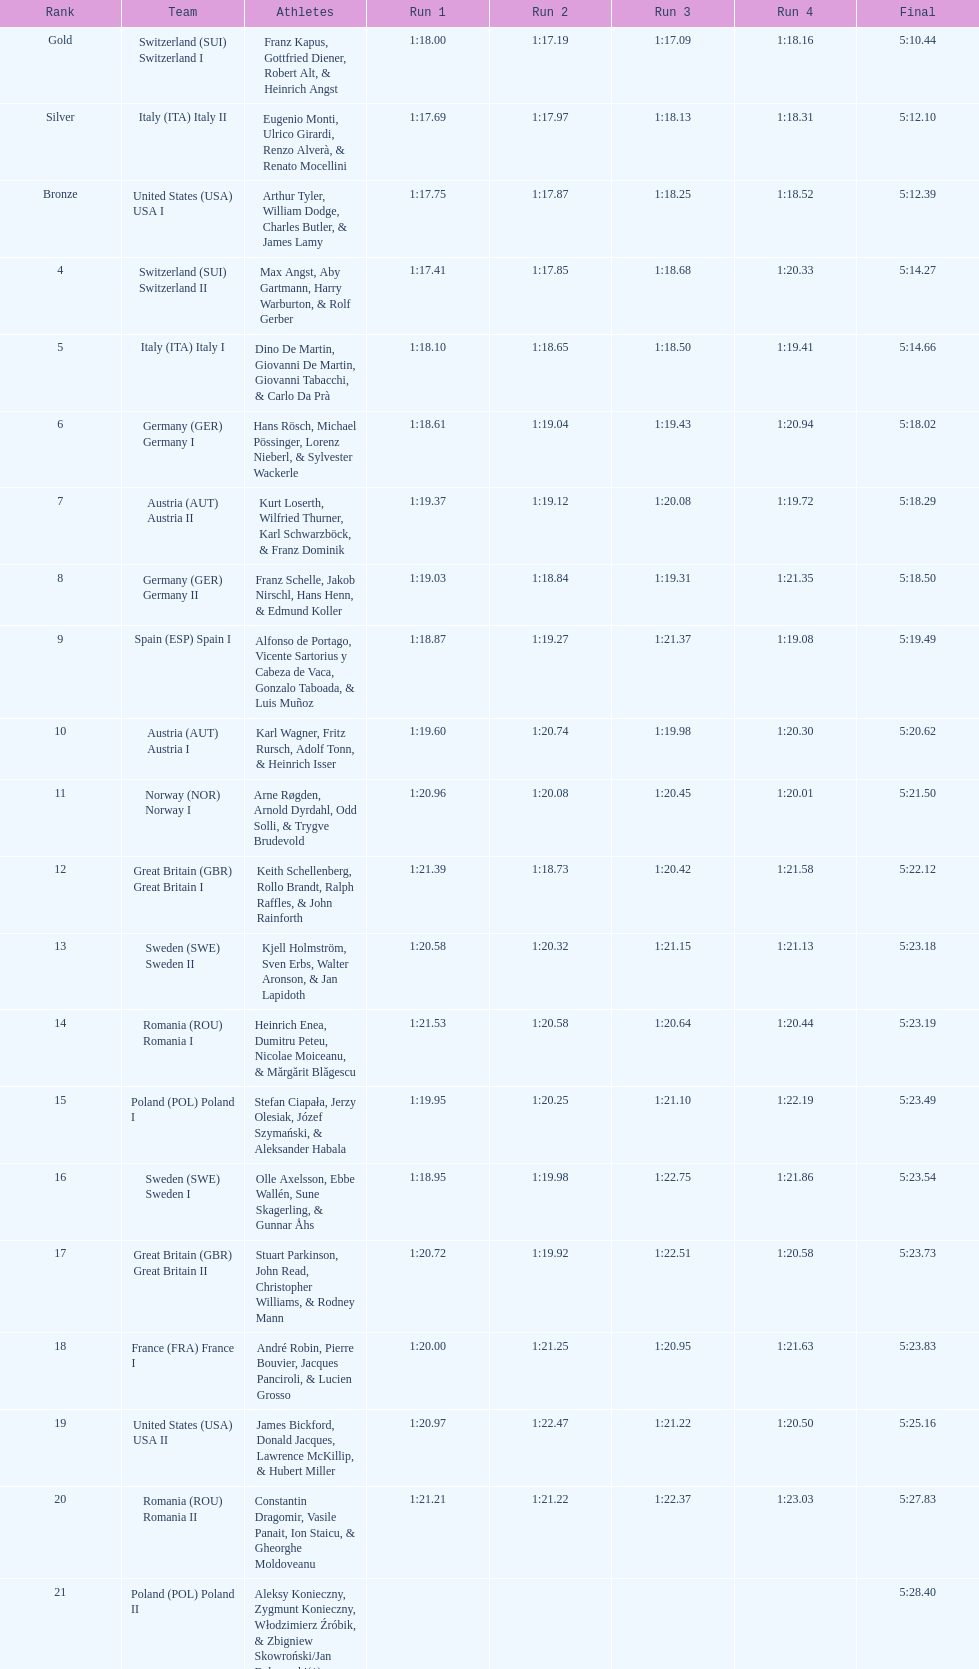Which team finished penultimate? Romania. 